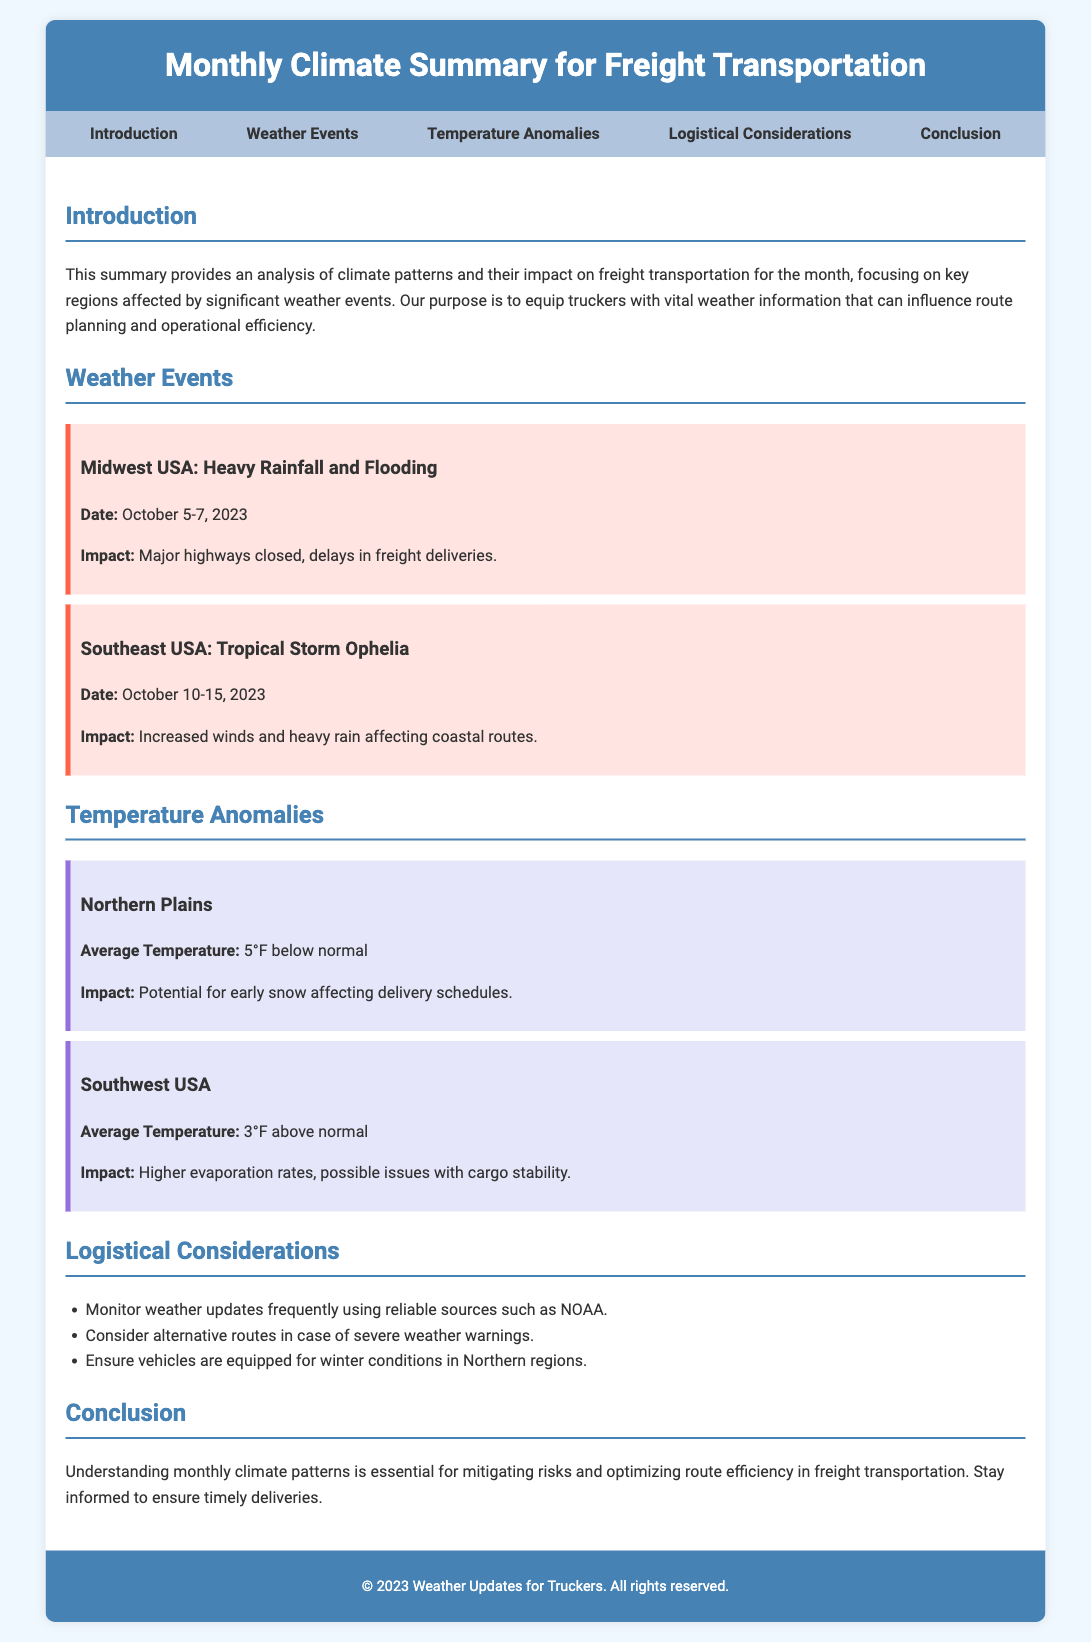What is the title of the document? The title is provided in the header section of the document, which is "Monthly Climate Summary for Freight Transportation."
Answer: Monthly Climate Summary for Freight Transportation What two major weather events are mentioned? The weather events are detailed in the respective sections, including significant impacts for truckers. The events are "Heavy Rainfall and Flooding" and "Tropical Storm Ophelia."
Answer: Heavy Rainfall and Flooding; Tropical Storm Ophelia What was the impact of Tropical Storm Ophelia? The impact is described in the alert section for Tropical Storm Ophelia, noting increased winds and heavy rain affecting routes.
Answer: Increased winds and heavy rain affecting coastal routes What is the average temperature anomaly in the Northern Plains? The average temperature is specified in the temperature anomalies section for the Northern Plains.
Answer: 5°F below normal What should truckers do regarding weather updates? This advice is given in the logistical considerations section, outlining actions truckers should take to respond to changing weather.
Answer: Monitor weather updates frequently What date range is associated with the weather event in the Midwest USA? The date for the weather event is provided in the alert for Midwest USA, indicating when the impacts were felt.
Answer: October 5-7, 2023 What are the potential issues related to temperature in the Southwest USA? The impact of temperature in the Southwest USA includes specific challenges mentioned in the temperature anomalies section.
Answer: Possible issues with cargo stability Which region is advised to ensure vehicles are equipped for winter conditions? The logistical considerations section specifies regions where winter readiness is important, particularly for the Northern region.
Answer: Northern regions 